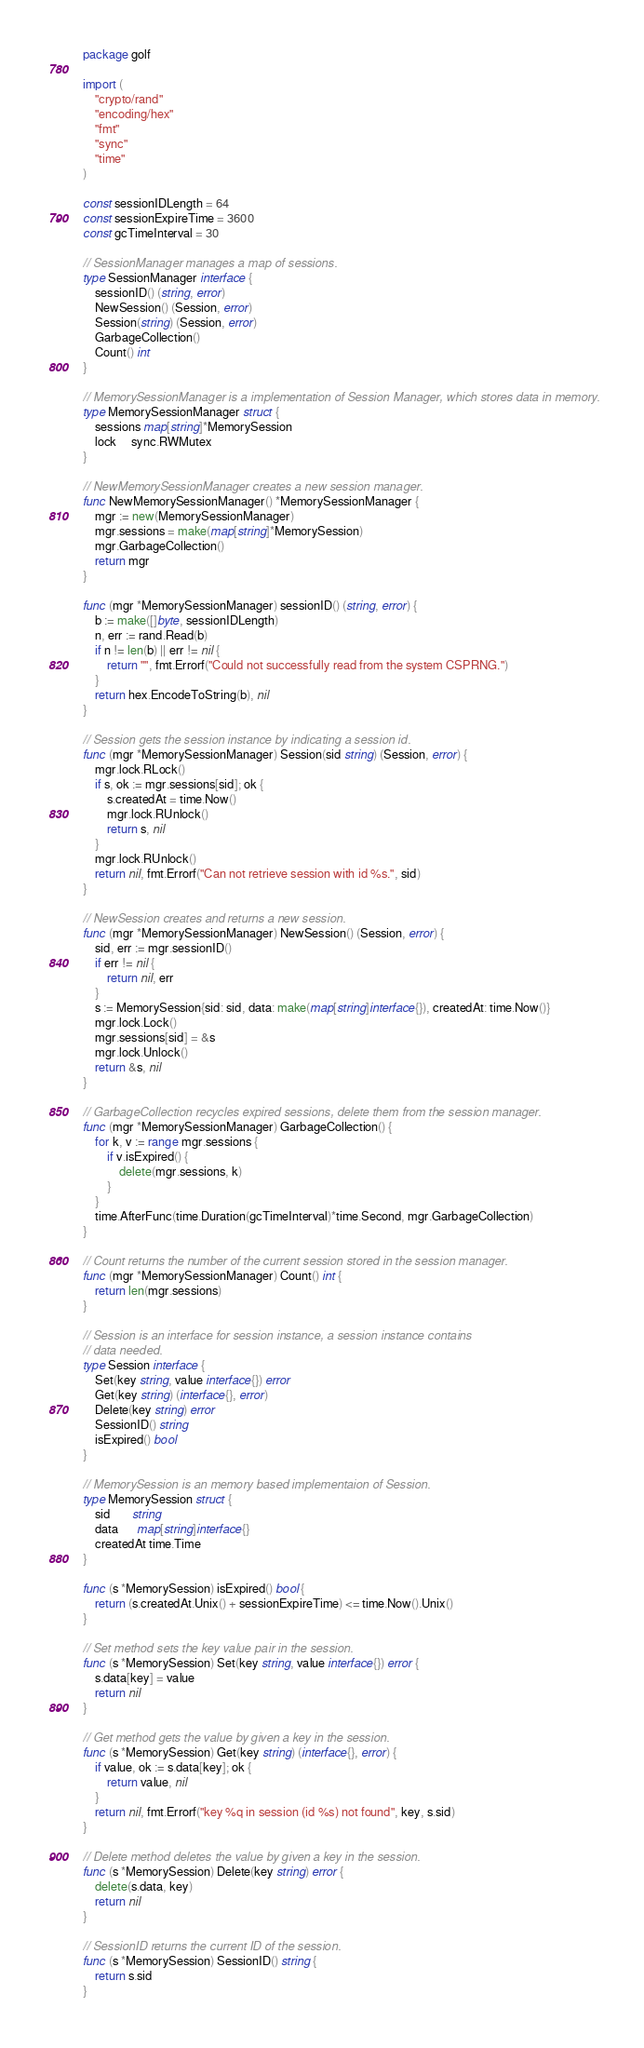<code> <loc_0><loc_0><loc_500><loc_500><_Go_>package golf

import (
	"crypto/rand"
	"encoding/hex"
	"fmt"
	"sync"
	"time"
)

const sessionIDLength = 64
const sessionExpireTime = 3600
const gcTimeInterval = 30

// SessionManager manages a map of sessions.
type SessionManager interface {
	sessionID() (string, error)
	NewSession() (Session, error)
	Session(string) (Session, error)
	GarbageCollection()
	Count() int
}

// MemorySessionManager is a implementation of Session Manager, which stores data in memory.
type MemorySessionManager struct {
	sessions map[string]*MemorySession
	lock     sync.RWMutex
}

// NewMemorySessionManager creates a new session manager.
func NewMemorySessionManager() *MemorySessionManager {
	mgr := new(MemorySessionManager)
	mgr.sessions = make(map[string]*MemorySession)
	mgr.GarbageCollection()
	return mgr
}

func (mgr *MemorySessionManager) sessionID() (string, error) {
	b := make([]byte, sessionIDLength)
	n, err := rand.Read(b)
	if n != len(b) || err != nil {
		return "", fmt.Errorf("Could not successfully read from the system CSPRNG.")
	}
	return hex.EncodeToString(b), nil
}

// Session gets the session instance by indicating a session id.
func (mgr *MemorySessionManager) Session(sid string) (Session, error) {
	mgr.lock.RLock()
	if s, ok := mgr.sessions[sid]; ok {
		s.createdAt = time.Now()
		mgr.lock.RUnlock()
		return s, nil
	}
	mgr.lock.RUnlock()
	return nil, fmt.Errorf("Can not retrieve session with id %s.", sid)
}

// NewSession creates and returns a new session.
func (mgr *MemorySessionManager) NewSession() (Session, error) {
	sid, err := mgr.sessionID()
	if err != nil {
		return nil, err
	}
	s := MemorySession{sid: sid, data: make(map[string]interface{}), createdAt: time.Now()}
	mgr.lock.Lock()
	mgr.sessions[sid] = &s
	mgr.lock.Unlock()
	return &s, nil
}

// GarbageCollection recycles expired sessions, delete them from the session manager.
func (mgr *MemorySessionManager) GarbageCollection() {
	for k, v := range mgr.sessions {
		if v.isExpired() {
			delete(mgr.sessions, k)
		}
	}
	time.AfterFunc(time.Duration(gcTimeInterval)*time.Second, mgr.GarbageCollection)
}

// Count returns the number of the current session stored in the session manager.
func (mgr *MemorySessionManager) Count() int {
	return len(mgr.sessions)
}

// Session is an interface for session instance, a session instance contains
// data needed.
type Session interface {
	Set(key string, value interface{}) error
	Get(key string) (interface{}, error)
	Delete(key string) error
	SessionID() string
	isExpired() bool
}

// MemorySession is an memory based implementaion of Session.
type MemorySession struct {
	sid       string
	data      map[string]interface{}
	createdAt time.Time
}

func (s *MemorySession) isExpired() bool {
	return (s.createdAt.Unix() + sessionExpireTime) <= time.Now().Unix()
}

// Set method sets the key value pair in the session.
func (s *MemorySession) Set(key string, value interface{}) error {
	s.data[key] = value
	return nil
}

// Get method gets the value by given a key in the session.
func (s *MemorySession) Get(key string) (interface{}, error) {
	if value, ok := s.data[key]; ok {
		return value, nil
	}
	return nil, fmt.Errorf("key %q in session (id %s) not found", key, s.sid)
}

// Delete method deletes the value by given a key in the session.
func (s *MemorySession) Delete(key string) error {
	delete(s.data, key)
	return nil
}

// SessionID returns the current ID of the session.
func (s *MemorySession) SessionID() string {
	return s.sid
}
</code> 